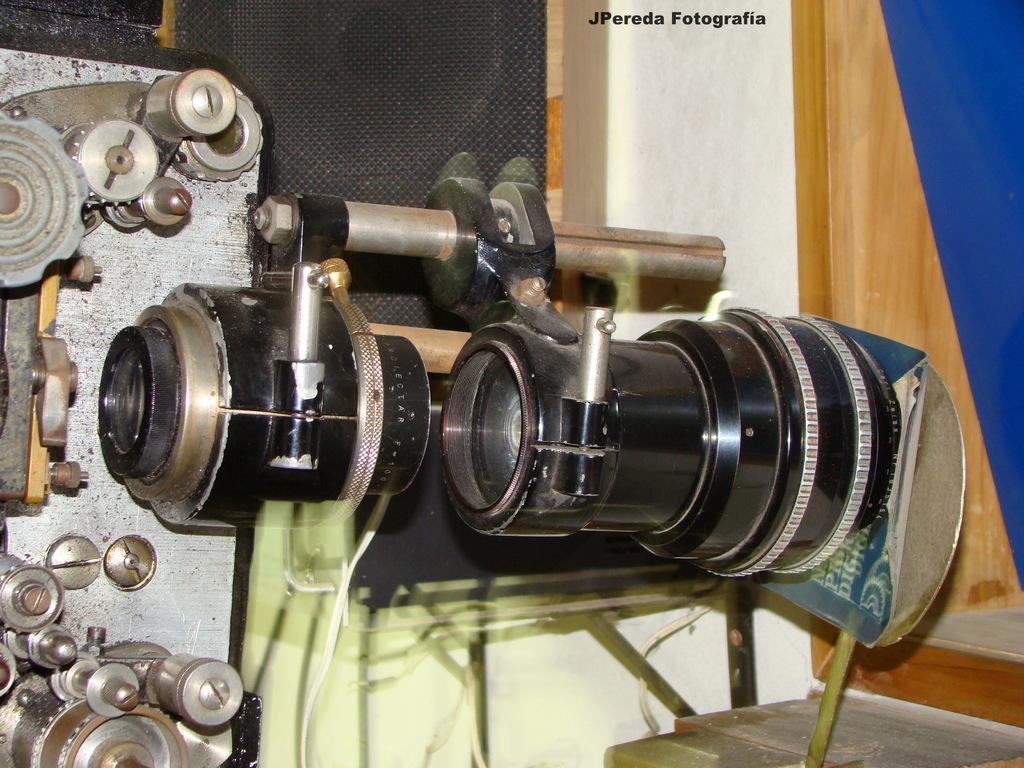What type of equipment is featured in the image? There is a machine tool and a camera lens in the image. What else can be seen in the image besides the equipment? There are objects in the image. Is there any text or marking visible in the image? Yes, there is a watermark at the top portion of the image. Can you describe the mountain range visible in the image? There is no mountain range present in the image; it features a machine tool, a camera lens, and other objects. How many children are playing in the image? There are no children present in the image. 